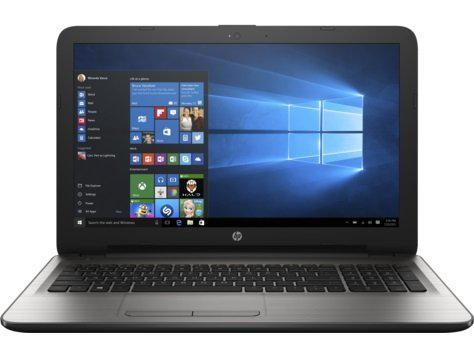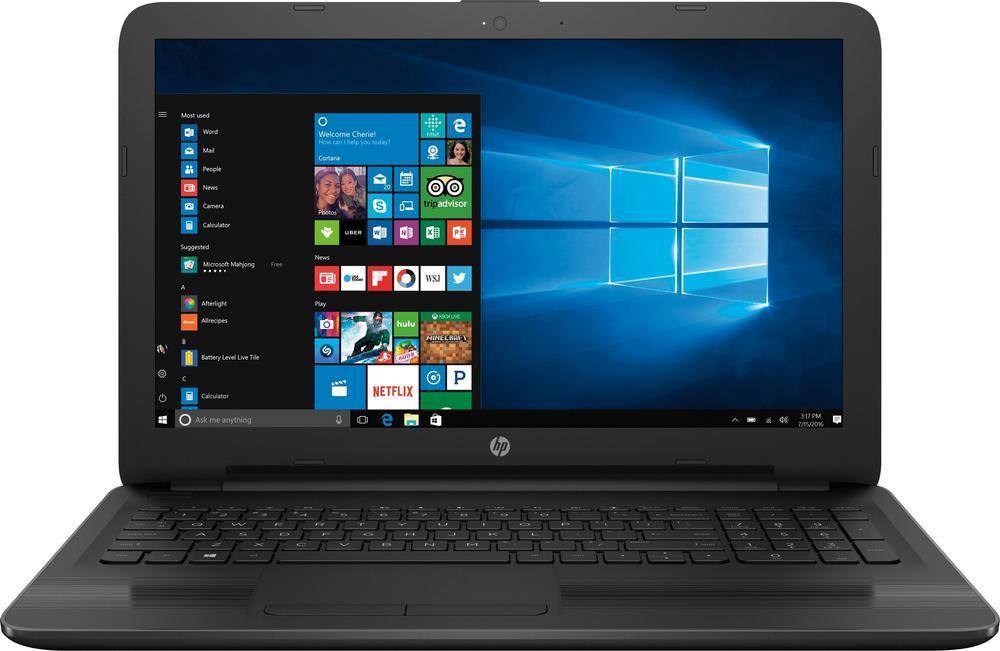The first image is the image on the left, the second image is the image on the right. Analyze the images presented: Is the assertion "At least one laptop is pictured against a black background." valid? Answer yes or no. No. 